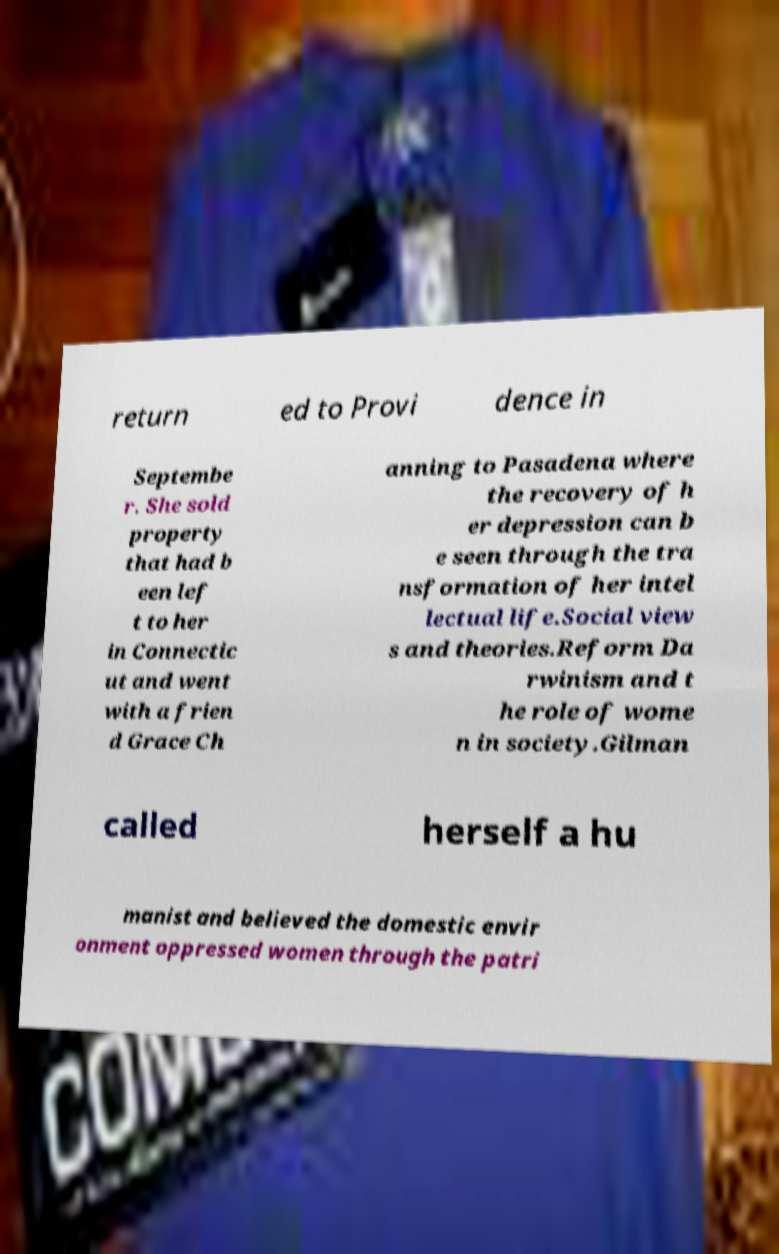What messages or text are displayed in this image? I need them in a readable, typed format. return ed to Provi dence in Septembe r. She sold property that had b een lef t to her in Connectic ut and went with a frien d Grace Ch anning to Pasadena where the recovery of h er depression can b e seen through the tra nsformation of her intel lectual life.Social view s and theories.Reform Da rwinism and t he role of wome n in society.Gilman called herself a hu manist and believed the domestic envir onment oppressed women through the patri 